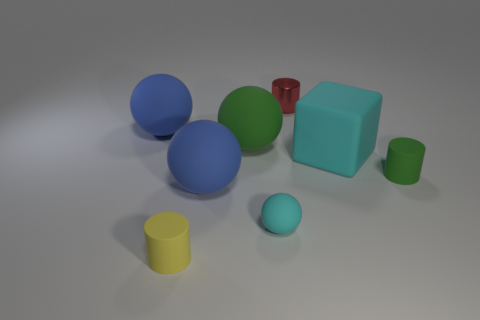Do the cyan matte sphere in front of the big cyan cube and the blue object left of the yellow matte cylinder have the same size? Upon examining the shapes and their relative sizes in the image, we can ascertain that the cyan matte sphere and the blue sphere do not share the same dimensions. The cyan sphere in front of the larger cyan cube appears to be smaller in diameter compared to the blue sphere situated to the left of the yellow matte cylinder. 